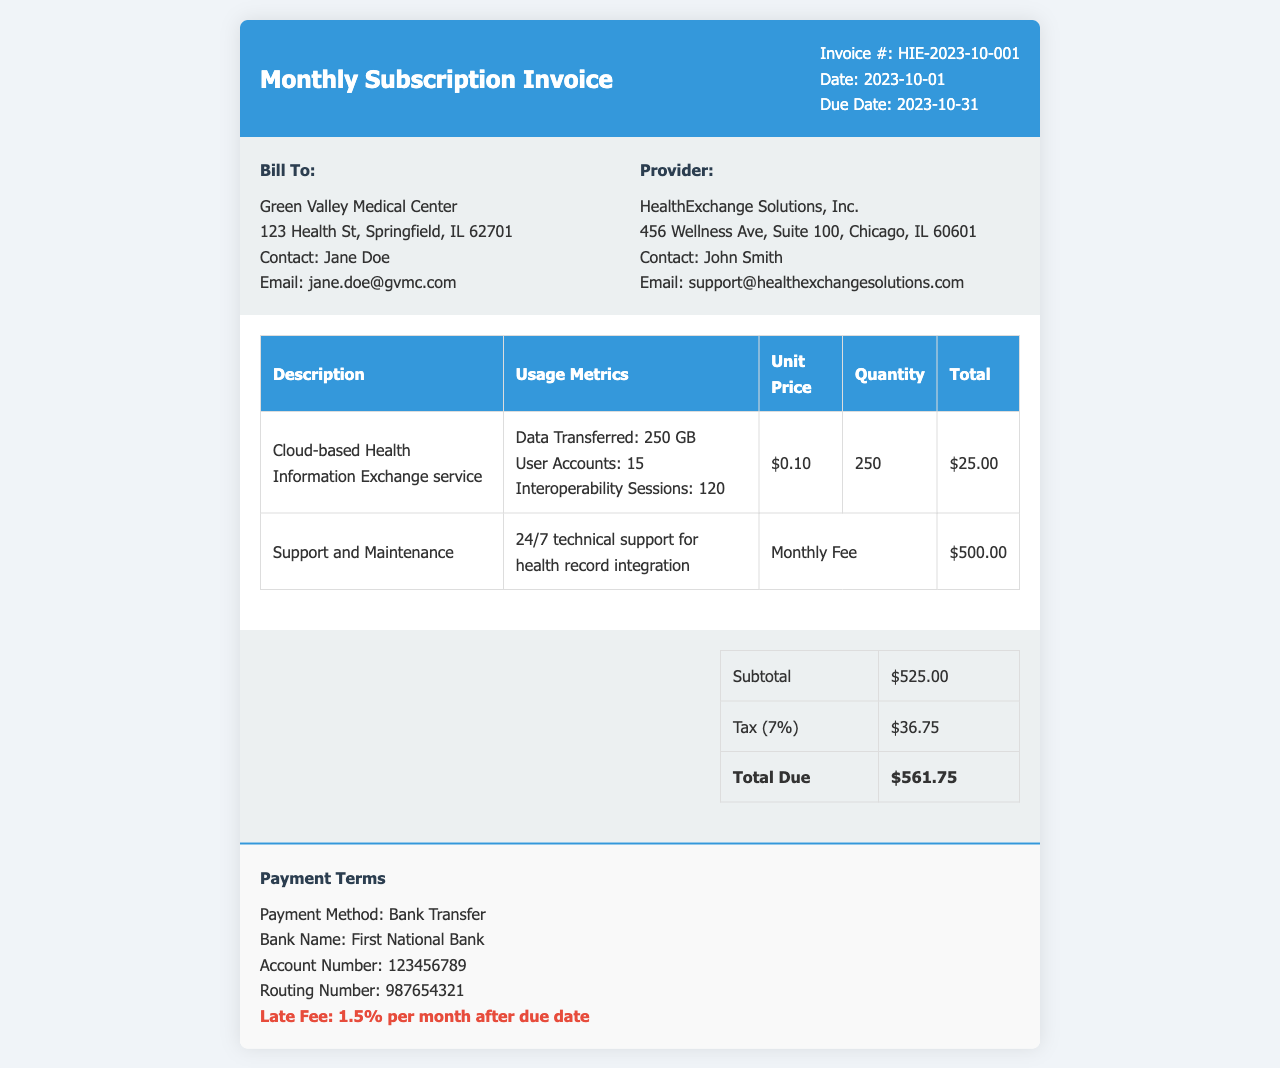What is the invoice number? The invoice number is clearly stated at the top of the document as Invoice #: HIE-2023-10-001.
Answer: HIE-2023-10-001 What is the due date? The due date is mentioned in the invoice, which is due on 2023-10-31.
Answer: 2023-10-31 Who is the contact for billing? The contact for billing is indicated under "Bill To" and is Jane Doe.
Answer: Jane Doe What is the subtotal amount? The subtotal amount is listed in the summary table as $525.00.
Answer: $525.00 How much tax is applied? The tax amount is shown in the summary table as Tax (7%) which totals $36.75.
Answer: $36.75 What is the total due? The total due is emphasized in the summary table as Total Due and equals $561.75.
Answer: $561.75 What services are included in this invoice? The services included are Cloud-based Health Information Exchange service and Support and Maintenance.
Answer: Cloud-based Health Information Exchange service, Support and Maintenance What is the payment method mentioned? The payment method is stated as Bank Transfer.
Answer: Bank Transfer Is there a late fee? Yes, the invoice mentions a late fee of 1.5% per month after due date.
Answer: 1.5% per month 